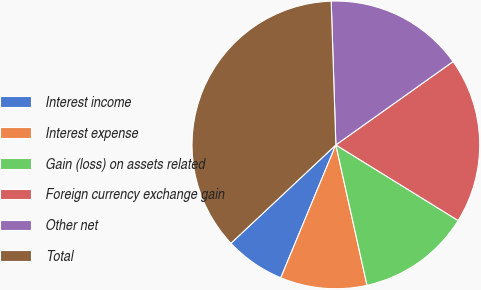Convert chart. <chart><loc_0><loc_0><loc_500><loc_500><pie_chart><fcel>Interest income<fcel>Interest expense<fcel>Gain (loss) on assets related<fcel>Foreign currency exchange gain<fcel>Other net<fcel>Total<nl><fcel>6.76%<fcel>9.73%<fcel>12.71%<fcel>18.65%<fcel>15.68%<fcel>36.47%<nl></chart> 